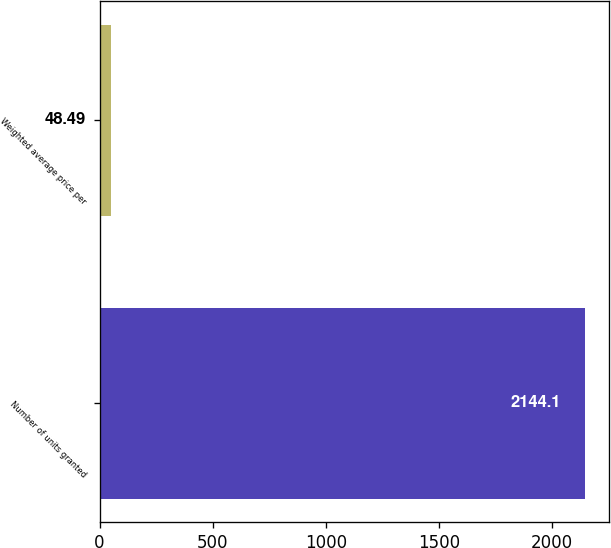<chart> <loc_0><loc_0><loc_500><loc_500><bar_chart><fcel>Number of units granted<fcel>Weighted average price per<nl><fcel>2144.1<fcel>48.49<nl></chart> 